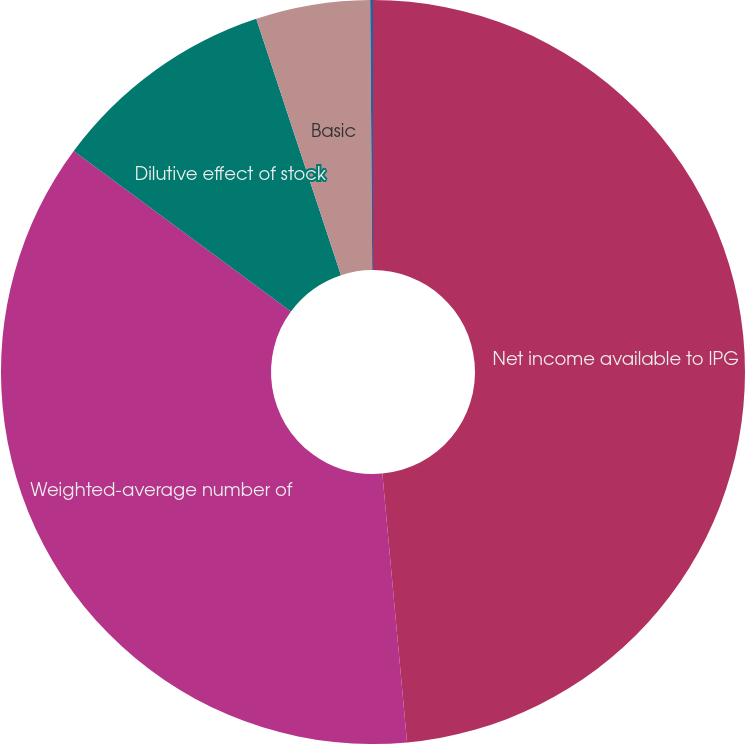<chart> <loc_0><loc_0><loc_500><loc_500><pie_chart><fcel>Net income available to IPG<fcel>Weighted-average number of<fcel>Dilutive effect of stock<fcel>Basic<fcel>Diluted<nl><fcel>48.54%<fcel>36.58%<fcel>9.8%<fcel>4.96%<fcel>0.12%<nl></chart> 